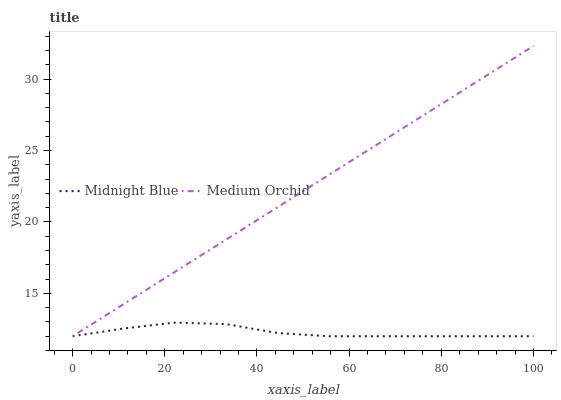Does Midnight Blue have the minimum area under the curve?
Answer yes or no. Yes. Does Medium Orchid have the maximum area under the curve?
Answer yes or no. Yes. Does Midnight Blue have the maximum area under the curve?
Answer yes or no. No. Is Medium Orchid the smoothest?
Answer yes or no. Yes. Is Midnight Blue the roughest?
Answer yes or no. Yes. Is Midnight Blue the smoothest?
Answer yes or no. No. Does Medium Orchid have the highest value?
Answer yes or no. Yes. Does Midnight Blue have the highest value?
Answer yes or no. No. 